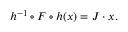Convert formula to latex. <formula><loc_0><loc_0><loc_500><loc_500>h ^ { - 1 } \circ F \circ h ( x ) = J \cdot x .</formula> 